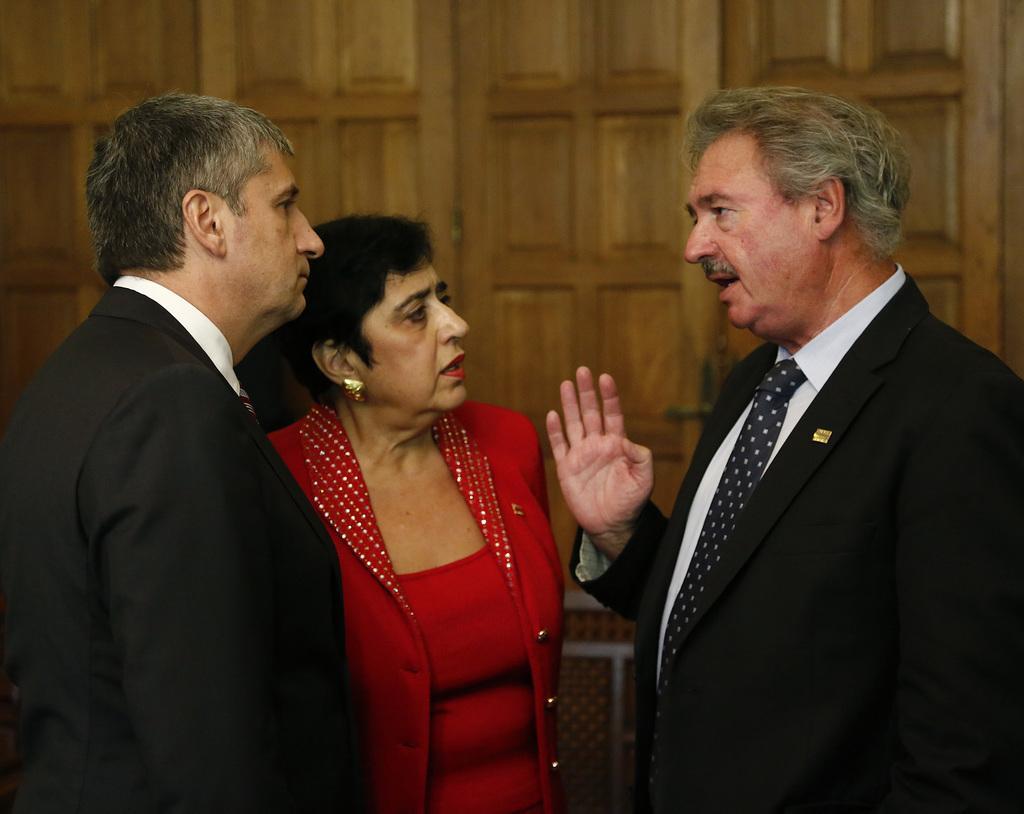Could you give a brief overview of what you see in this image? In this image there are two men and a woman standing. Behind them there is a wooden wall. 